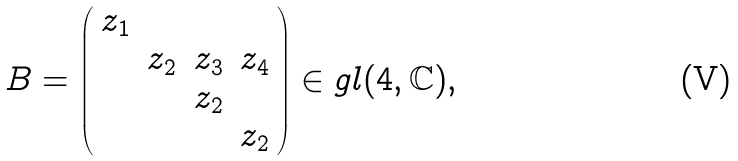Convert formula to latex. <formula><loc_0><loc_0><loc_500><loc_500>B = \left ( \begin{array} { c c c c } z _ { 1 } & & & \\ & z _ { 2 } & z _ { 3 } & z _ { 4 } \\ & & z _ { 2 } & \\ & & & z _ { 2 } \end{array} \right ) \in g l ( 4 , \mathbb { C } ) ,</formula> 